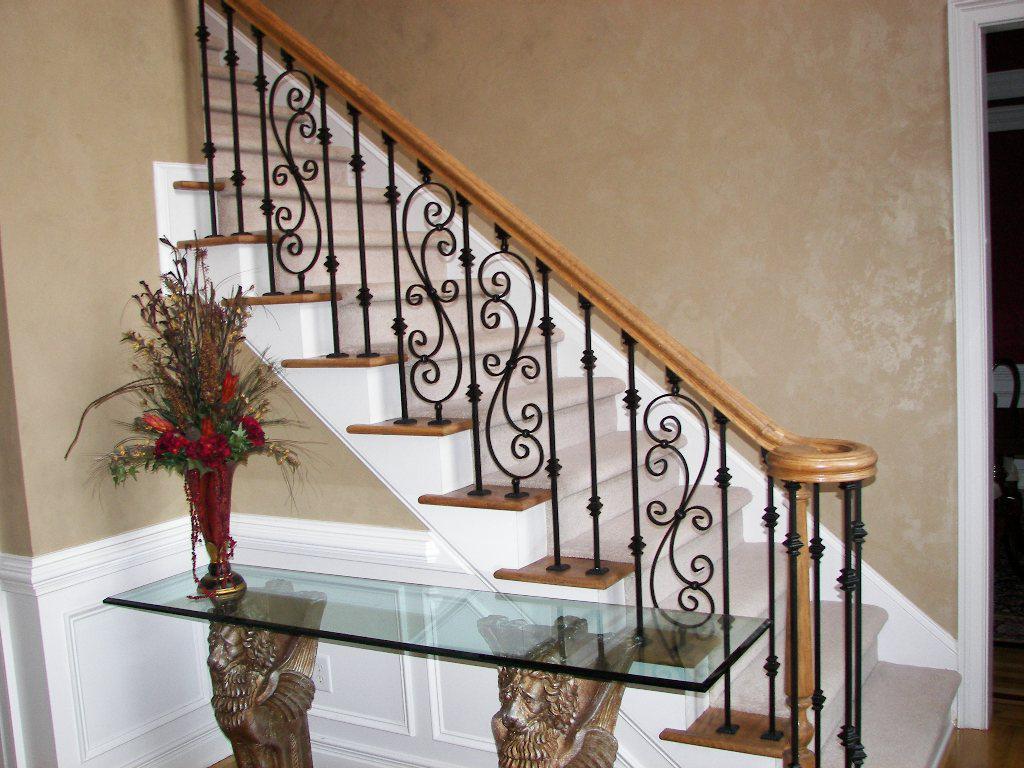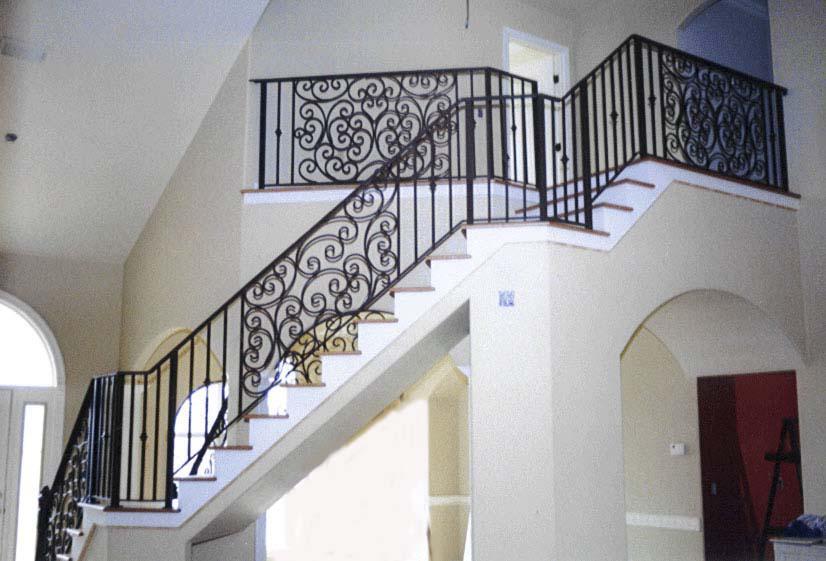The first image is the image on the left, the second image is the image on the right. Considering the images on both sides, is "The left and right image contains the same number of staircase with wooden and metal S shaped rails." valid? Answer yes or no. No. The first image is the image on the left, the second image is the image on the right. Assess this claim about the two images: "The left image shows a leftward ascending staircase with a wooden handrail and black wrought iron bars accented with overlapping scroll shapes.". Correct or not? Answer yes or no. Yes. 